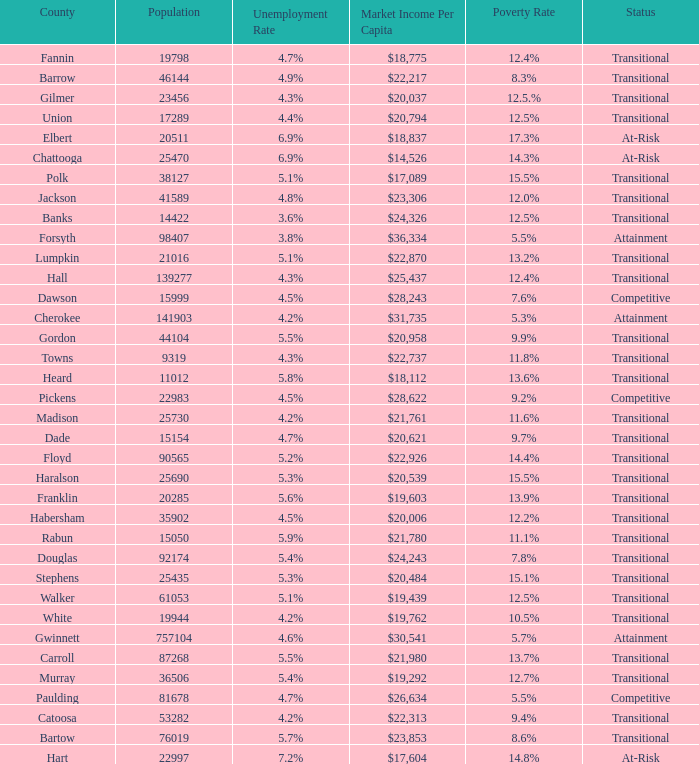What is the unemployment rate for the county with a market income per capita of $20,958? 1.0. 